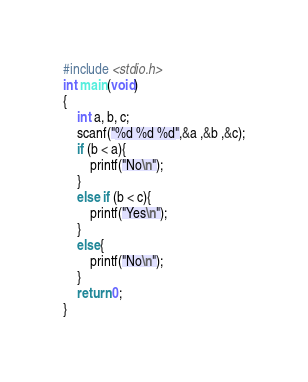Convert code to text. <code><loc_0><loc_0><loc_500><loc_500><_C_>#include <stdio.h>
int main(void)
{
	int a, b, c;
	scanf("%d %d %d",&a ,&b ,&c);
	if (b < a){
		printf("No\n");
	}
	else if (b < c){
		printf("Yes\n");
	}
	else{
		printf("No\n");
	}
	return 0;
}</code> 